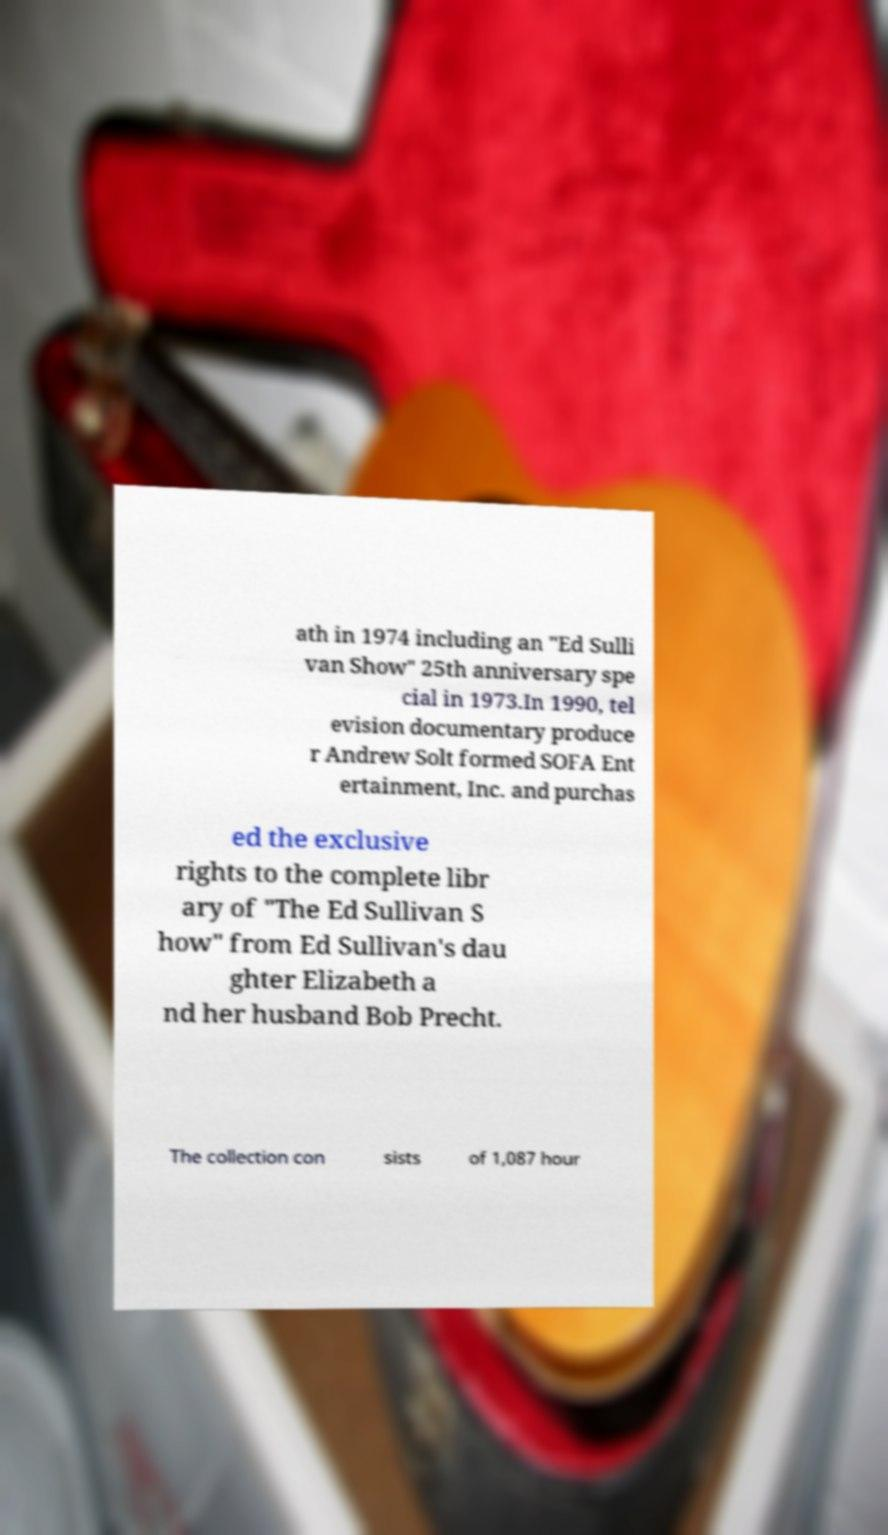For documentation purposes, I need the text within this image transcribed. Could you provide that? ath in 1974 including an "Ed Sulli van Show" 25th anniversary spe cial in 1973.In 1990, tel evision documentary produce r Andrew Solt formed SOFA Ent ertainment, Inc. and purchas ed the exclusive rights to the complete libr ary of "The Ed Sullivan S how" from Ed Sullivan's dau ghter Elizabeth a nd her husband Bob Precht. The collection con sists of 1,087 hour 